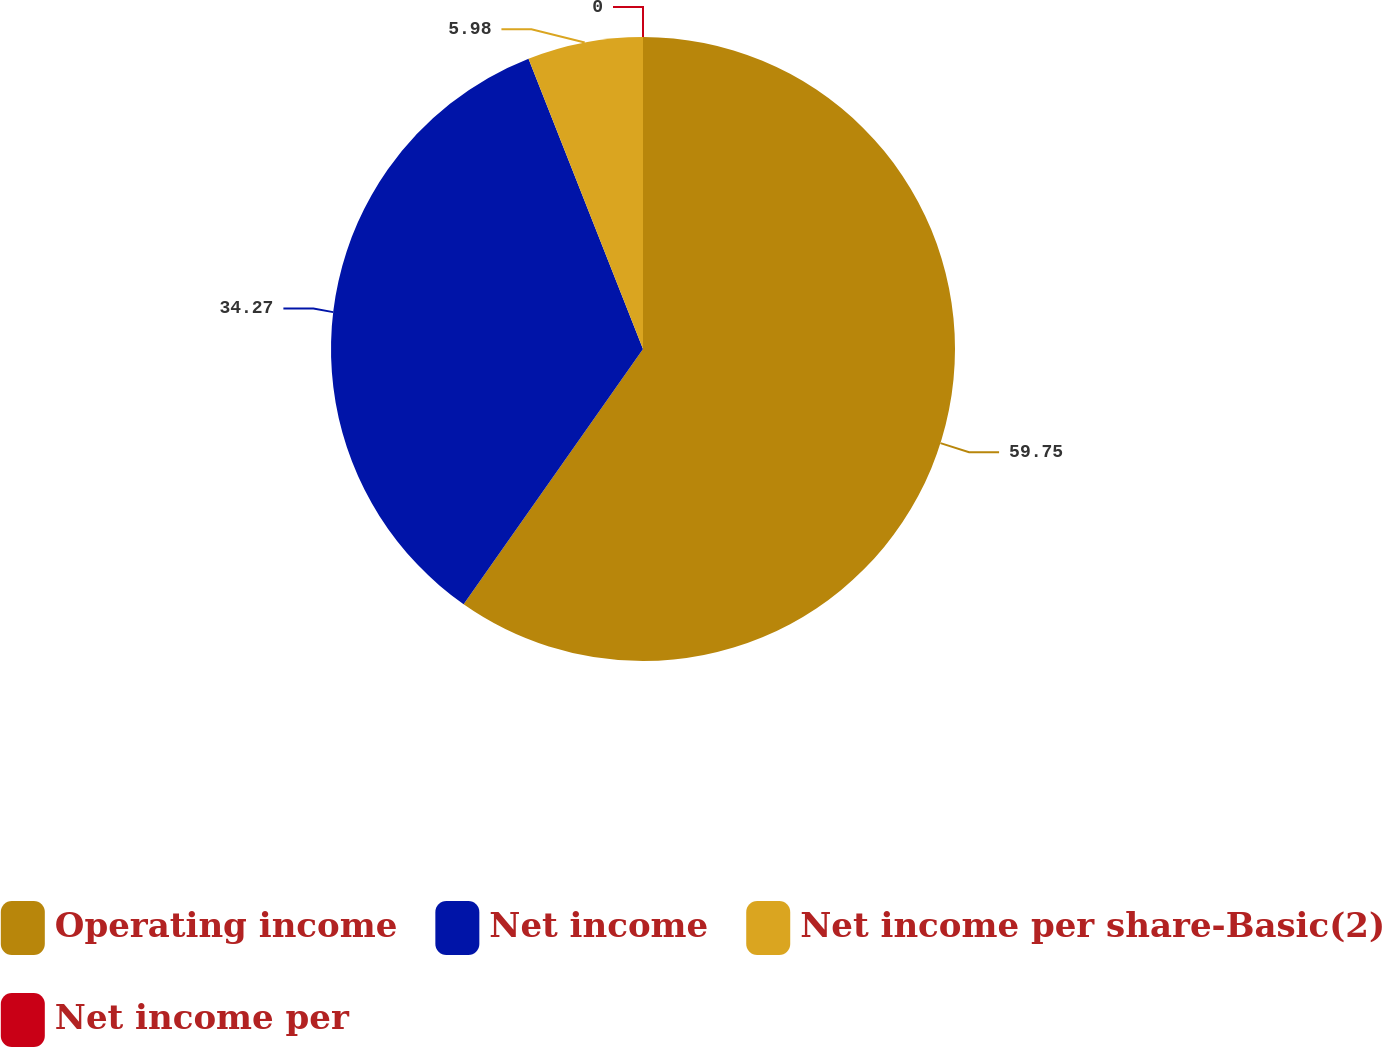<chart> <loc_0><loc_0><loc_500><loc_500><pie_chart><fcel>Operating income<fcel>Net income<fcel>Net income per share-Basic(2)<fcel>Net income per<nl><fcel>59.75%<fcel>34.27%<fcel>5.98%<fcel>0.0%<nl></chart> 